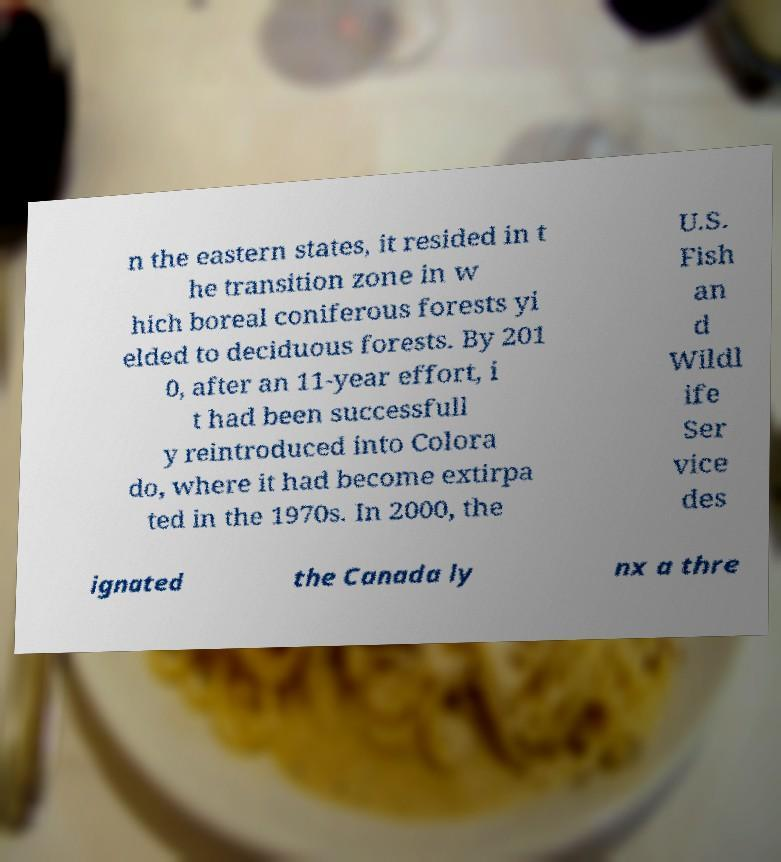Could you extract and type out the text from this image? n the eastern states, it resided in t he transition zone in w hich boreal coniferous forests yi elded to deciduous forests. By 201 0, after an 11-year effort, i t had been successfull y reintroduced into Colora do, where it had become extirpa ted in the 1970s. In 2000, the U.S. Fish an d Wildl ife Ser vice des ignated the Canada ly nx a thre 